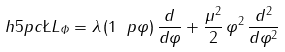<formula> <loc_0><loc_0><loc_500><loc_500>\ h { 5 p c } \L L _ { \varPhi } = \lambda \, ( 1 \ p \varphi ) \, \frac { d } { d \varphi } + \frac { \mu ^ { 2 } } { 2 } \, \varphi ^ { 2 } \, \frac { d ^ { 2 } } { d \varphi ^ { 2 } }</formula> 